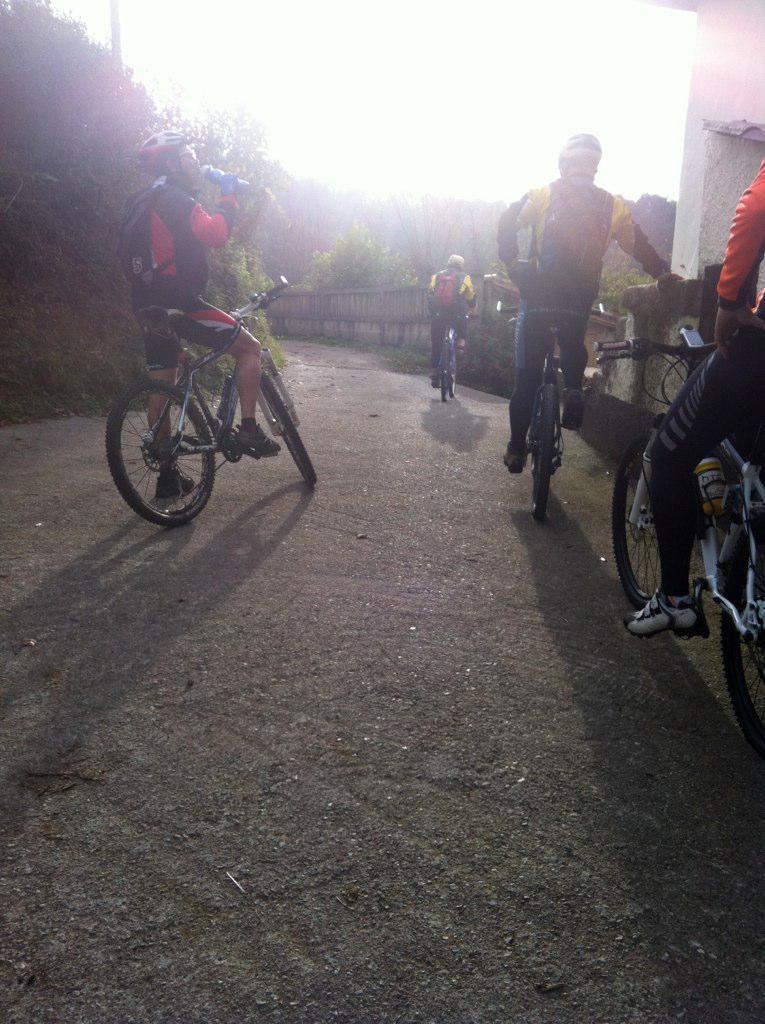Please provide a concise description of this image. In a picture there are many people riding a bicycle there are many trees there is a mountain there is a clear sky. 